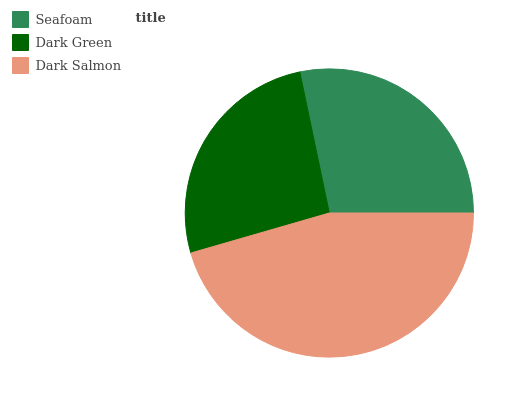Is Dark Green the minimum?
Answer yes or no. Yes. Is Dark Salmon the maximum?
Answer yes or no. Yes. Is Dark Salmon the minimum?
Answer yes or no. No. Is Dark Green the maximum?
Answer yes or no. No. Is Dark Salmon greater than Dark Green?
Answer yes or no. Yes. Is Dark Green less than Dark Salmon?
Answer yes or no. Yes. Is Dark Green greater than Dark Salmon?
Answer yes or no. No. Is Dark Salmon less than Dark Green?
Answer yes or no. No. Is Seafoam the high median?
Answer yes or no. Yes. Is Seafoam the low median?
Answer yes or no. Yes. Is Dark Salmon the high median?
Answer yes or no. No. Is Dark Salmon the low median?
Answer yes or no. No. 